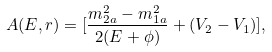<formula> <loc_0><loc_0><loc_500><loc_500>A ( E , r ) = [ \frac { m _ { 2 a } ^ { 2 } - m _ { 1 a } ^ { 2 } } { 2 ( E + \phi ) } + ( V _ { 2 } - V _ { 1 } ) ] ,</formula> 